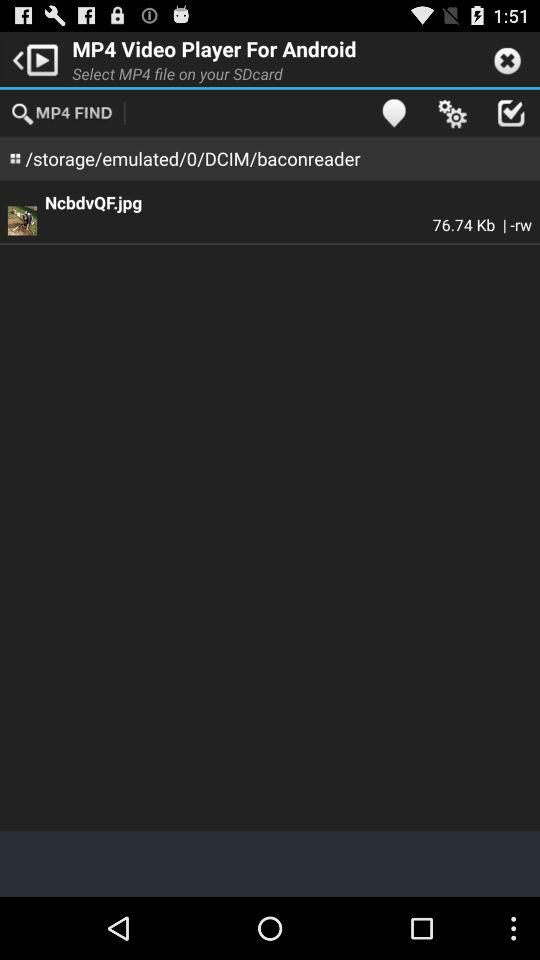What is the size of the image? The size of the image is 76.74 KB. 